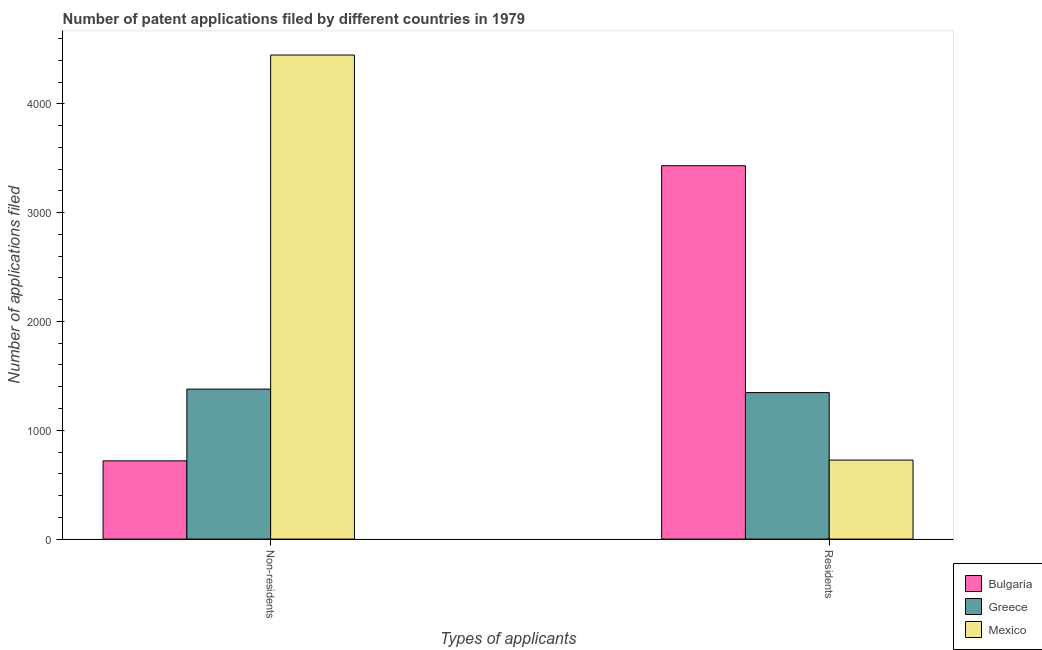How many different coloured bars are there?
Your answer should be compact. 3. How many groups of bars are there?
Your response must be concise. 2. Are the number of bars per tick equal to the number of legend labels?
Your response must be concise. Yes. How many bars are there on the 1st tick from the left?
Provide a short and direct response. 3. What is the label of the 2nd group of bars from the left?
Make the answer very short. Residents. What is the number of patent applications by residents in Mexico?
Offer a terse response. 726. Across all countries, what is the maximum number of patent applications by residents?
Your answer should be compact. 3431. Across all countries, what is the minimum number of patent applications by residents?
Provide a succinct answer. 726. What is the total number of patent applications by residents in the graph?
Give a very brief answer. 5503. What is the difference between the number of patent applications by residents in Greece and that in Bulgaria?
Give a very brief answer. -2085. What is the difference between the number of patent applications by residents in Greece and the number of patent applications by non residents in Mexico?
Provide a short and direct response. -3102. What is the average number of patent applications by residents per country?
Keep it short and to the point. 1834.33. What is the difference between the number of patent applications by non residents and number of patent applications by residents in Bulgaria?
Your response must be concise. -2712. In how many countries, is the number of patent applications by residents greater than 1600 ?
Give a very brief answer. 1. What is the ratio of the number of patent applications by non residents in Mexico to that in Greece?
Ensure brevity in your answer.  3.23. Is the number of patent applications by non residents in Bulgaria less than that in Greece?
Your answer should be compact. Yes. What does the 2nd bar from the right in Residents represents?
Give a very brief answer. Greece. How many bars are there?
Ensure brevity in your answer.  6. How many countries are there in the graph?
Your answer should be compact. 3. Are the values on the major ticks of Y-axis written in scientific E-notation?
Your response must be concise. No. Does the graph contain grids?
Offer a very short reply. No. Where does the legend appear in the graph?
Keep it short and to the point. Bottom right. How many legend labels are there?
Make the answer very short. 3. How are the legend labels stacked?
Offer a very short reply. Vertical. What is the title of the graph?
Your response must be concise. Number of patent applications filed by different countries in 1979. What is the label or title of the X-axis?
Offer a terse response. Types of applicants. What is the label or title of the Y-axis?
Ensure brevity in your answer.  Number of applications filed. What is the Number of applications filed of Bulgaria in Non-residents?
Give a very brief answer. 719. What is the Number of applications filed in Greece in Non-residents?
Your answer should be compact. 1378. What is the Number of applications filed in Mexico in Non-residents?
Offer a terse response. 4448. What is the Number of applications filed in Bulgaria in Residents?
Provide a short and direct response. 3431. What is the Number of applications filed of Greece in Residents?
Your answer should be compact. 1346. What is the Number of applications filed in Mexico in Residents?
Your answer should be very brief. 726. Across all Types of applicants, what is the maximum Number of applications filed of Bulgaria?
Your response must be concise. 3431. Across all Types of applicants, what is the maximum Number of applications filed of Greece?
Give a very brief answer. 1378. Across all Types of applicants, what is the maximum Number of applications filed of Mexico?
Your answer should be compact. 4448. Across all Types of applicants, what is the minimum Number of applications filed of Bulgaria?
Make the answer very short. 719. Across all Types of applicants, what is the minimum Number of applications filed in Greece?
Your response must be concise. 1346. Across all Types of applicants, what is the minimum Number of applications filed in Mexico?
Provide a succinct answer. 726. What is the total Number of applications filed in Bulgaria in the graph?
Your answer should be very brief. 4150. What is the total Number of applications filed of Greece in the graph?
Keep it short and to the point. 2724. What is the total Number of applications filed of Mexico in the graph?
Offer a very short reply. 5174. What is the difference between the Number of applications filed of Bulgaria in Non-residents and that in Residents?
Make the answer very short. -2712. What is the difference between the Number of applications filed of Greece in Non-residents and that in Residents?
Provide a succinct answer. 32. What is the difference between the Number of applications filed in Mexico in Non-residents and that in Residents?
Give a very brief answer. 3722. What is the difference between the Number of applications filed of Bulgaria in Non-residents and the Number of applications filed of Greece in Residents?
Your response must be concise. -627. What is the difference between the Number of applications filed in Bulgaria in Non-residents and the Number of applications filed in Mexico in Residents?
Give a very brief answer. -7. What is the difference between the Number of applications filed of Greece in Non-residents and the Number of applications filed of Mexico in Residents?
Your response must be concise. 652. What is the average Number of applications filed of Bulgaria per Types of applicants?
Make the answer very short. 2075. What is the average Number of applications filed in Greece per Types of applicants?
Your response must be concise. 1362. What is the average Number of applications filed in Mexico per Types of applicants?
Your answer should be compact. 2587. What is the difference between the Number of applications filed of Bulgaria and Number of applications filed of Greece in Non-residents?
Offer a very short reply. -659. What is the difference between the Number of applications filed of Bulgaria and Number of applications filed of Mexico in Non-residents?
Give a very brief answer. -3729. What is the difference between the Number of applications filed in Greece and Number of applications filed in Mexico in Non-residents?
Your answer should be compact. -3070. What is the difference between the Number of applications filed of Bulgaria and Number of applications filed of Greece in Residents?
Provide a short and direct response. 2085. What is the difference between the Number of applications filed in Bulgaria and Number of applications filed in Mexico in Residents?
Your response must be concise. 2705. What is the difference between the Number of applications filed in Greece and Number of applications filed in Mexico in Residents?
Your answer should be very brief. 620. What is the ratio of the Number of applications filed of Bulgaria in Non-residents to that in Residents?
Your answer should be very brief. 0.21. What is the ratio of the Number of applications filed in Greece in Non-residents to that in Residents?
Ensure brevity in your answer.  1.02. What is the ratio of the Number of applications filed in Mexico in Non-residents to that in Residents?
Keep it short and to the point. 6.13. What is the difference between the highest and the second highest Number of applications filed of Bulgaria?
Keep it short and to the point. 2712. What is the difference between the highest and the second highest Number of applications filed in Greece?
Offer a terse response. 32. What is the difference between the highest and the second highest Number of applications filed in Mexico?
Your response must be concise. 3722. What is the difference between the highest and the lowest Number of applications filed of Bulgaria?
Ensure brevity in your answer.  2712. What is the difference between the highest and the lowest Number of applications filed in Greece?
Offer a very short reply. 32. What is the difference between the highest and the lowest Number of applications filed in Mexico?
Your answer should be very brief. 3722. 